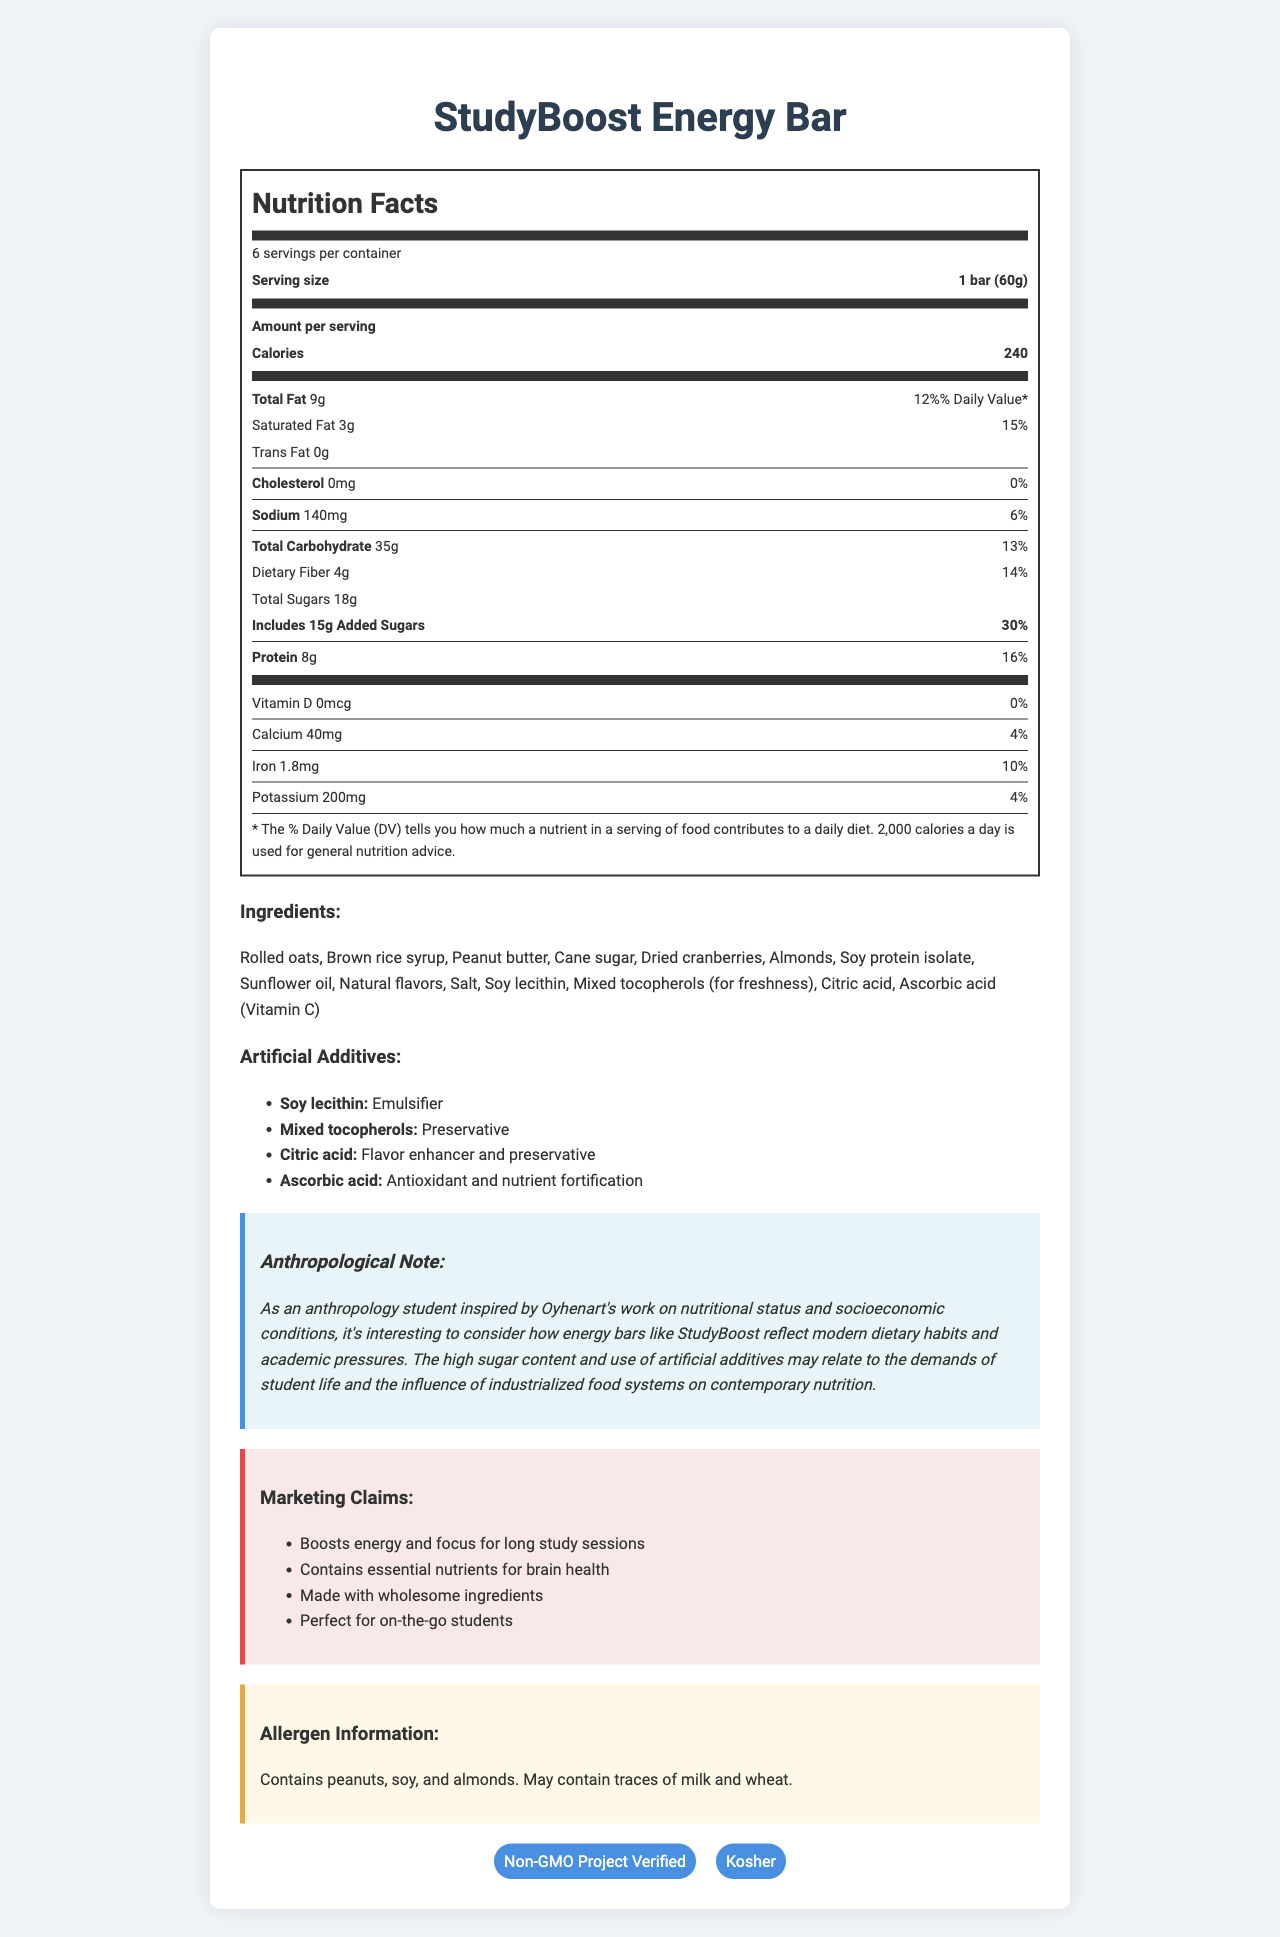what is the serving size for the StudyBoost Energy Bar? The serving size is clearly mentioned in the document as "1 bar (60g)".
Answer: 1 bar (60g) how many grams of total sugars does one serving of the StudyBoost Energy Bar contain? The document specifies "Total Sugars 18g" under the nutrition facts.
Answer: 18g what is the primary purpose of Soy lecithin in the StudyBoost Energy Bar? The artificial additives section indicates that Soy lecithin is used as an "Emulsifier".
Answer: Emulsifier which certification does the StudyBoost Energy Bar have? A. USDA Organic B. Fair Trade Certified C. Non-GMO Project Verified D. Gluten-Free The certification section shows "Non-GMO Project Verified" as one of the certifications.
Answer: C. Non-GMO Project Verified what is the percentage of daily value for added sugars in one serving of the StudyBoost Energy Bar? The nutrition facts show "Includes 15g Added Sugars 30%" under "Total Sugars".
Answer: 30% does the StudyBoost Energy Bar contain any cholesterol? The nutrition facts indicate "Cholesterol 0mg 0%" meaning it contains no cholesterol.
Answer: No what main ingredients contribute to the protein content in the StudyBoost Energy Bar? The ingredients list includes "Soy protein isolate" as one of the key ingredients.
Answer: Soy protein isolate how many calories are there in one serving of the StudyBoost Energy Bar? The nutrition facts clearly state "Calories 240".
Answer: 240 calories what is the significance of Ascorbic acid in the StudyBoost Energy Bar? A. Flavor B. Emulsifier C. Antioxidant and nutrient fortification D. Sweetener The artificial additives section states "Ascorbic acid: Antioxidant and nutrient fortification".
Answer: C. Antioxidant and nutrient fortification does the StudyBoost Energy Bar contain any dairy allergens? The allergen information mentions "May contain traces of milk".
Answer: May contain traces of milk describe the main purpose of the StudyBoost Energy Bar as portrayed in the document The marketing claims and the anthropological note emphasize the bar's design for students needing energy and nutritional support during study sessions. The ingredients and nutrition facts reveal insights into its composition, while allergen information and certifications detail additional product attributes.
Answer: The StudyBoost Energy Bar is marketed as a nutritious snack designed to boost energy and focus during long study sessions for students. It includes essential nutrients for brain health and is made with wholesome ingredients, intended for on-the-go consumption. However, it also contains high levels of added sugars and artificial additives, reflecting modern dietary habits and industrialized food systems' influence on nutrition. how does the StudyBoost Energy Bar contribute to daily iron intake? The nutrition facts indicate that one serving of the StudyBoost Energy Bar provides "Iron 1.8mg 10%".
Answer: 10% of daily value is the StudyBoost Energy Bar suitable for vegans? The document does not provide sufficient details to determine if the product is vegan; it lists some plant-based ingredients but mentions it may contain traces of milk.
Answer: Not enough information what is the function of Mixed tocopherols in the StudyBoost Energy Bar? The artificial additives section lists "Mixed tocopherols: Preservative".
Answer: Preservative what makes the StudyBoost Energy Bar appealing to its target audience of students? The marketing claims highlight it as an energy booster and nutrient source, which are appealing factors for students needing sustained focus and nutrition.
Answer: Boosts energy and focus for long study sessions and contains essential nutrients for brain health. 